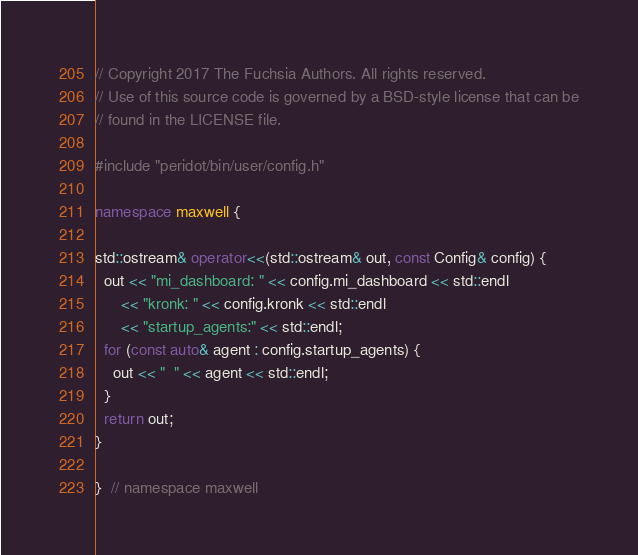<code> <loc_0><loc_0><loc_500><loc_500><_C++_>// Copyright 2017 The Fuchsia Authors. All rights reserved.
// Use of this source code is governed by a BSD-style license that can be
// found in the LICENSE file.

#include "peridot/bin/user/config.h"

namespace maxwell {

std::ostream& operator<<(std::ostream& out, const Config& config) {
  out << "mi_dashboard: " << config.mi_dashboard << std::endl
      << "kronk: " << config.kronk << std::endl
      << "startup_agents:" << std::endl;
  for (const auto& agent : config.startup_agents) {
    out << "  " << agent << std::endl;
  }
  return out;
}

}  // namespace maxwell
</code> 